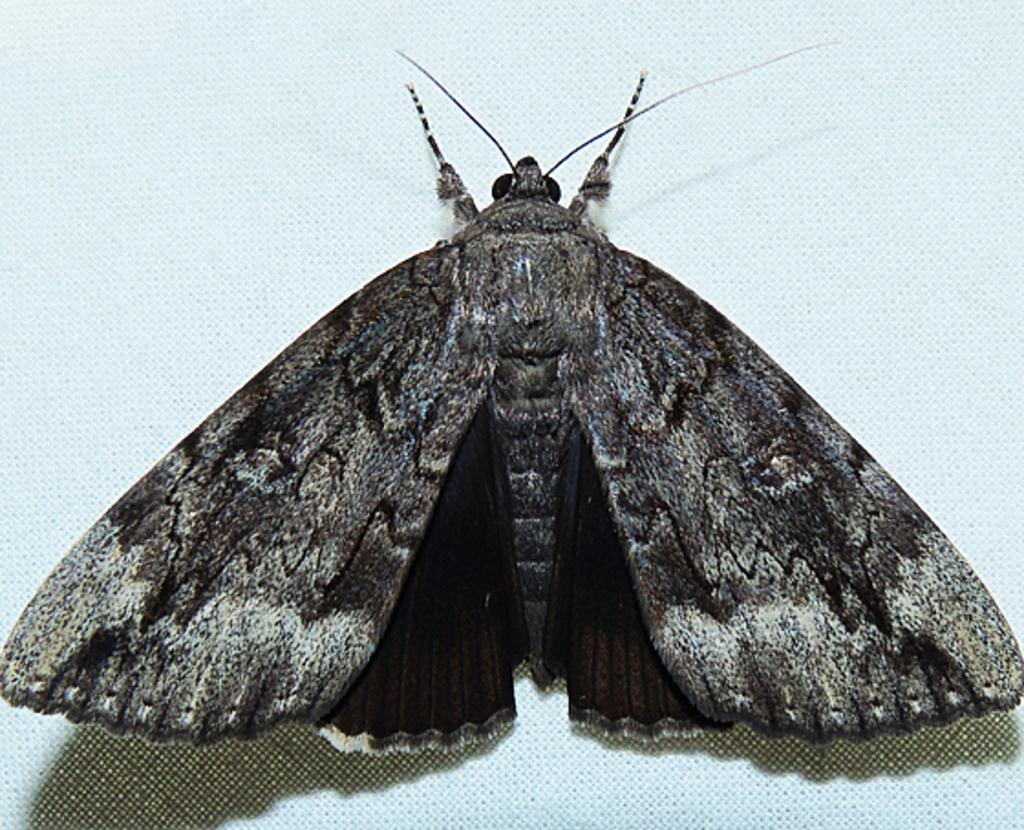What is the main subject of the image? The main subject of the image is a butterfly. Can you describe the color combination of the butterfly? The butterfly has a black and white color combination. What body parts does the butterfly have? The butterfly has wings and legs. Where is the butterfly located in the image? The butterfly is on a surface. What is the color of the background in the image? The background of the image is white. What type of hat is the butterfly wearing in the image? There is no hat present on the butterfly in the image. What is the butterfly eating for dinner in the image? Butterflies do not eat dinner, as they primarily feed on nectar from flowers. 